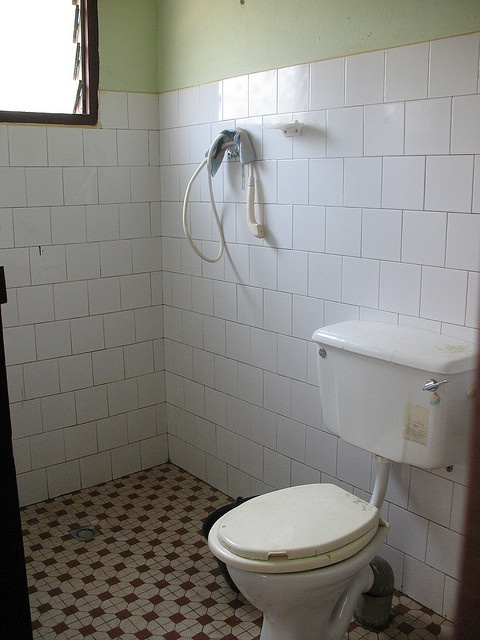Describe the objects in this image and their specific colors. I can see a toilet in white, darkgray, gray, lightgray, and black tones in this image. 